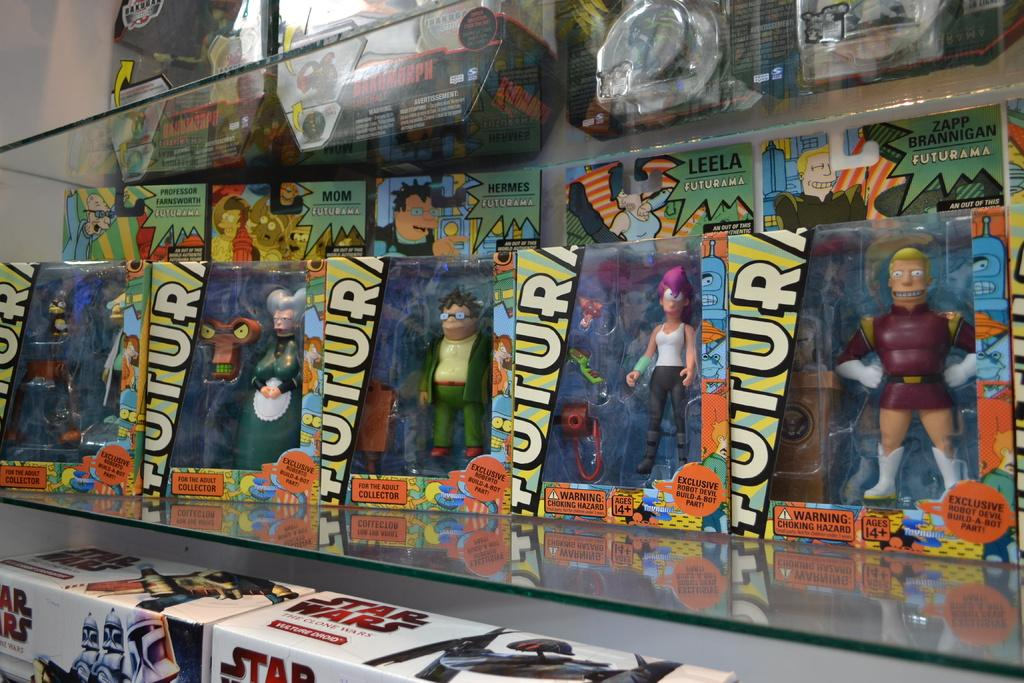<image>
Create a compact narrative representing the image presented. a group of toys with tutor on their package 